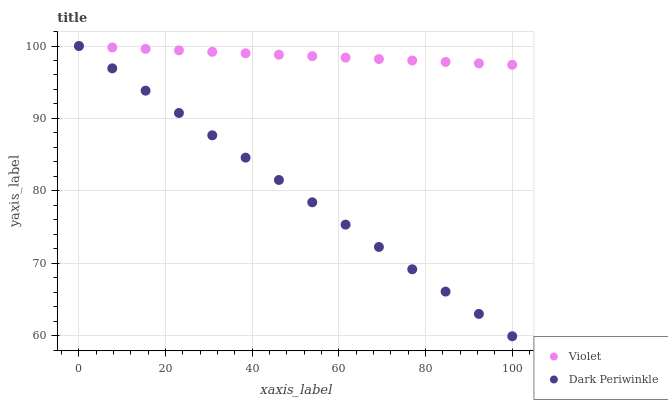Does Dark Periwinkle have the minimum area under the curve?
Answer yes or no. Yes. Does Violet have the maximum area under the curve?
Answer yes or no. Yes. Does Violet have the minimum area under the curve?
Answer yes or no. No. Is Dark Periwinkle the smoothest?
Answer yes or no. Yes. Is Violet the roughest?
Answer yes or no. Yes. Is Violet the smoothest?
Answer yes or no. No. Does Dark Periwinkle have the lowest value?
Answer yes or no. Yes. Does Violet have the lowest value?
Answer yes or no. No. Does Violet have the highest value?
Answer yes or no. Yes. Does Dark Periwinkle intersect Violet?
Answer yes or no. Yes. Is Dark Periwinkle less than Violet?
Answer yes or no. No. Is Dark Periwinkle greater than Violet?
Answer yes or no. No. 